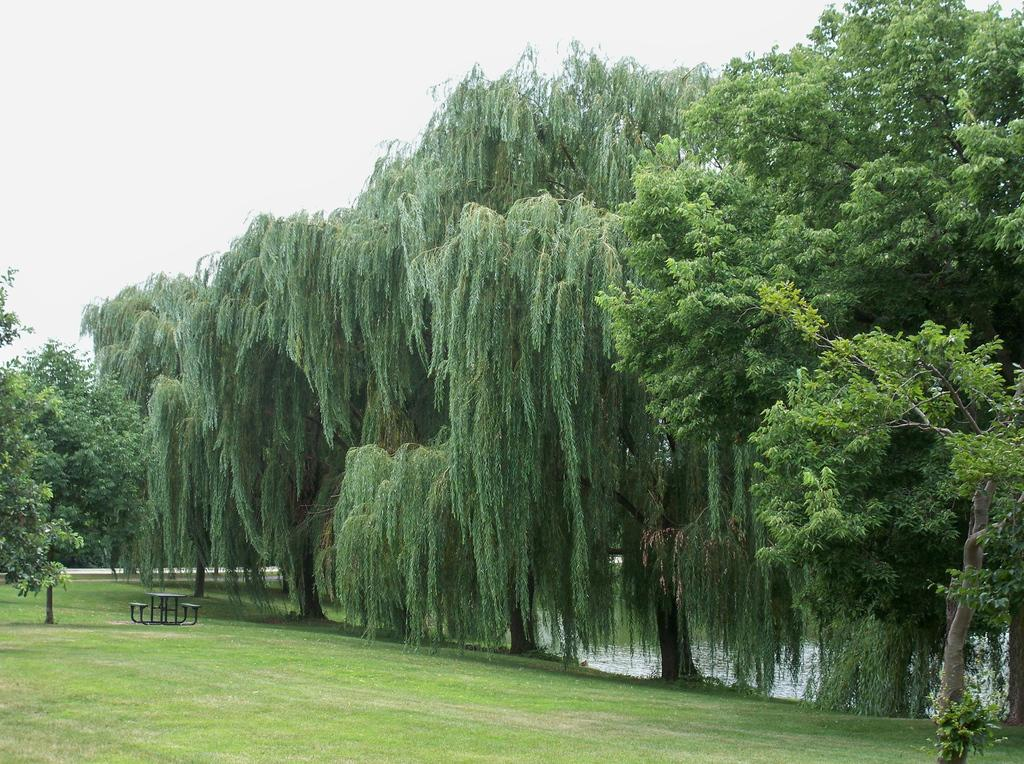What type of vegetation is present in the image? There is grass in the image. What type of seating is available in the image? There are benches in the image. What type of furniture is present in the image? There is a table in the image. What type of natural elements are present in the image? There are trees and water visible in the image. What can be seen in the background of the image? The sky is visible in the background of the image. What type of sheet is draped over the trees in the image? There is no sheet present in the image; the trees are not covered by any fabric. What type of smell can be detected in the image? The image does not convey any sense of smell, so it cannot be determined from the image. 